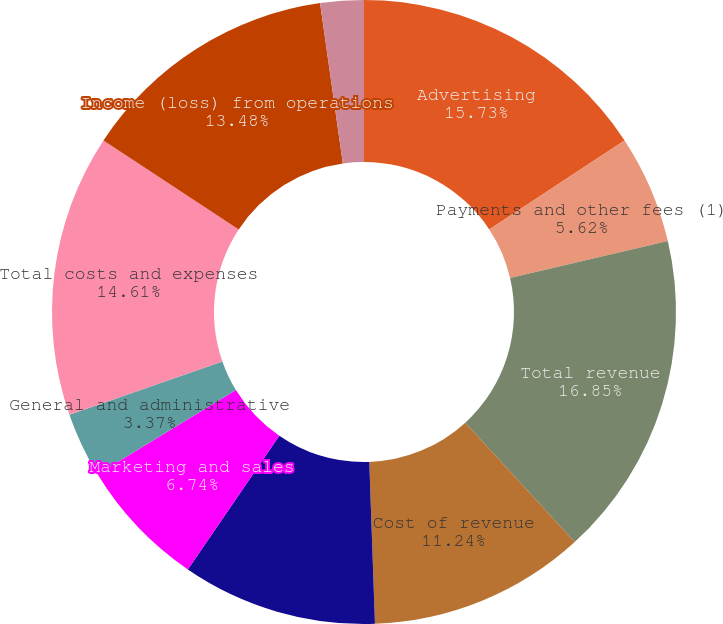Convert chart to OTSL. <chart><loc_0><loc_0><loc_500><loc_500><pie_chart><fcel>Advertising<fcel>Payments and other fees (1)<fcel>Total revenue<fcel>Cost of revenue<fcel>Research and development<fcel>Marketing and sales<fcel>General and administrative<fcel>Total costs and expenses<fcel>Income (loss) from operations<fcel>Interest and other income<nl><fcel>15.73%<fcel>5.62%<fcel>16.85%<fcel>11.24%<fcel>10.11%<fcel>6.74%<fcel>3.37%<fcel>14.61%<fcel>13.48%<fcel>2.25%<nl></chart> 